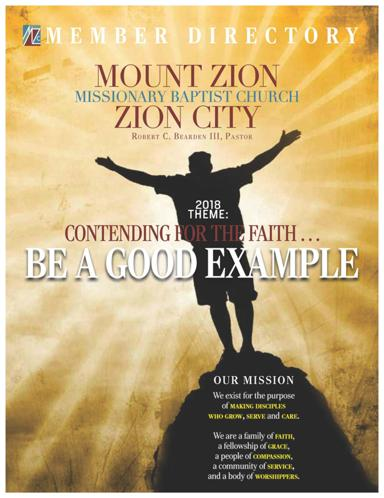What is the name of the church mentioned in the image? The church shown in the image is named Mount Zion Missionary Baptist Church, located in Zion City. This detail, along with the vibrant visual presentation in the directory cover, underlines the church's prominent place in the community. 